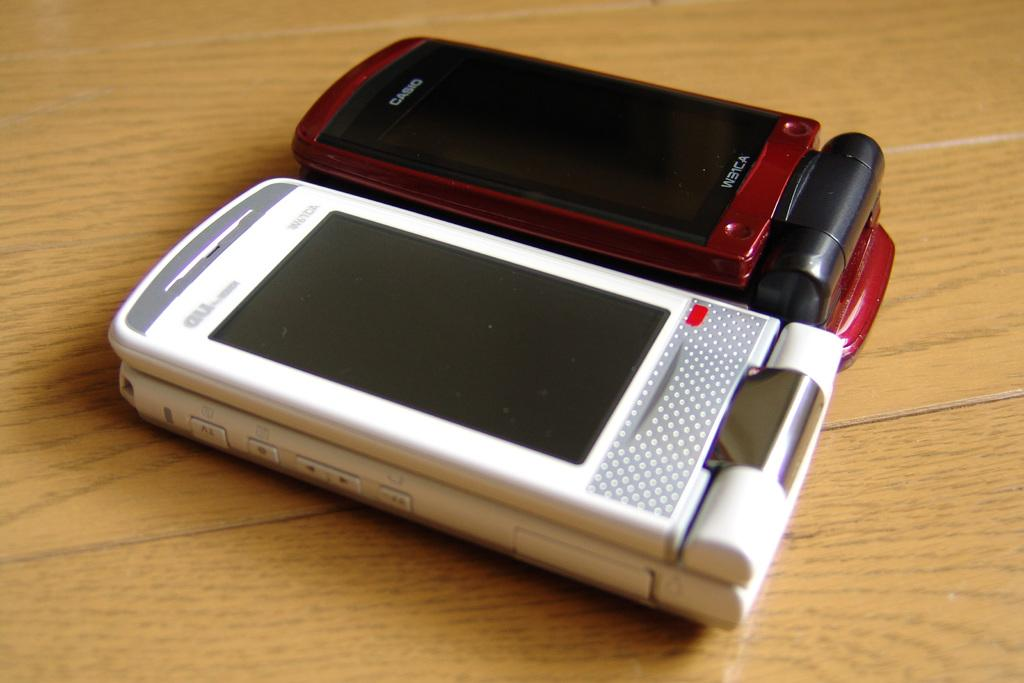<image>
Describe the image concisely. A red Casio flip phone next to a white flip phone. 